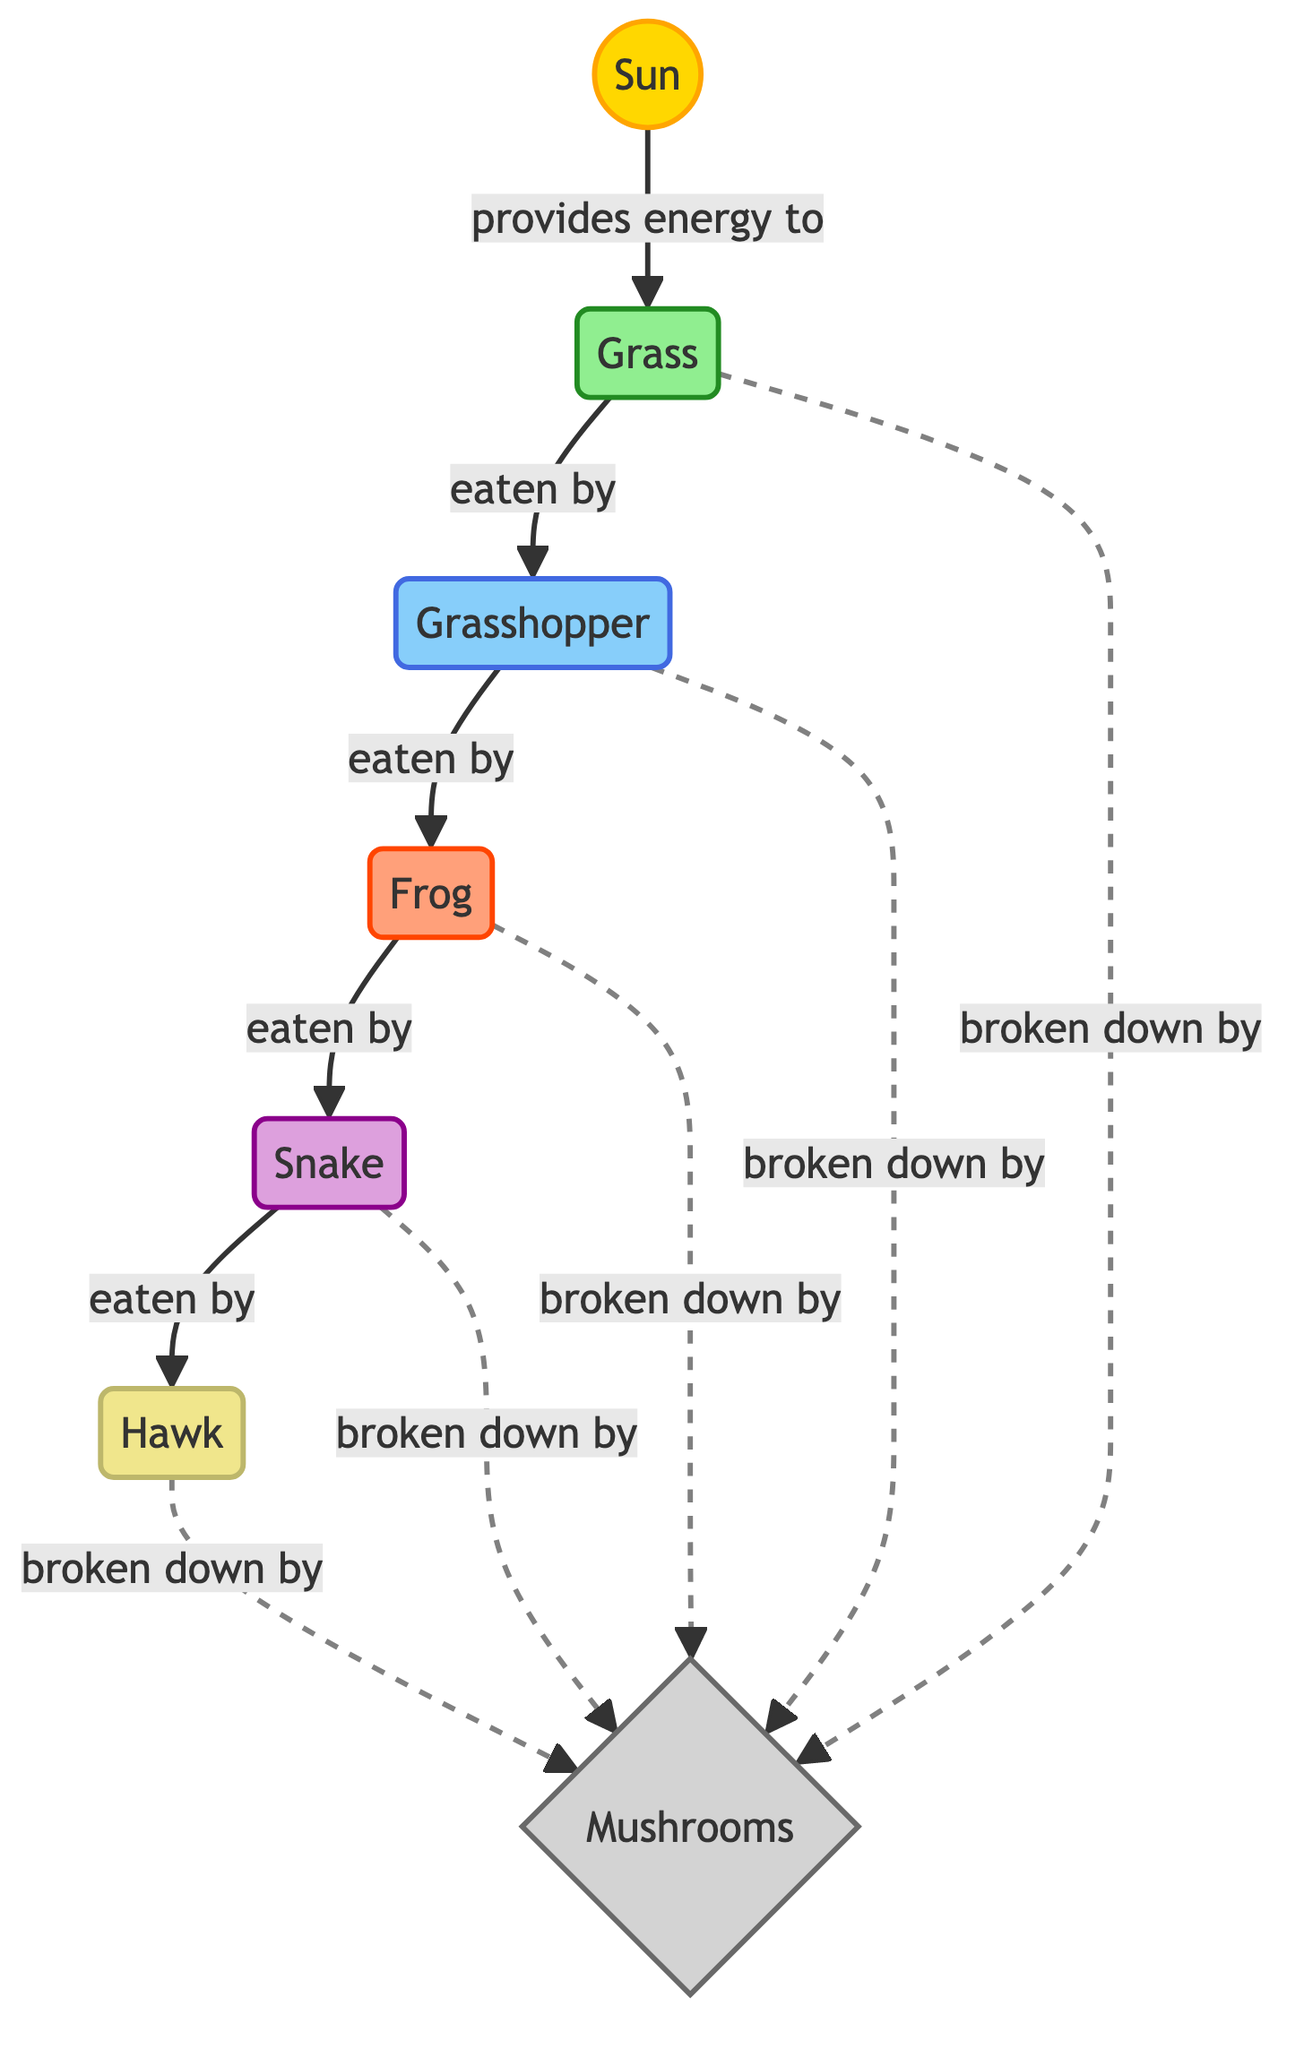What is the first trophic level in the diagram? The first trophic level is represented by the node labeled "Sun," which provides energy for the primary producer.
Answer: Sun How many primary consumers are in the diagram? The diagram shows one primary consumer, which is represented by the node labeled "Grasshopper."
Answer: 1 What organism is at the third trophic level? The third trophic level is occupied by the "Frog," which is a secondary consumer in the food chain.
Answer: Frog Which organism is broken down by decomposers? All organisms in the diagram are broken down by decomposers, including "Grass," "Grasshopper," "Frog," "Snake," and "Hawk." However, the question can refer to any specific one, such as "Hawk."
Answer: Hawk What relationship exists between the "Snake" and "Hawk"? The relationship is that the "Snake" is eaten by the "Hawk," as indicated by the arrow pointing from the Snake to the Hawk.
Answer: eaten by Why are mushrooms classified as decomposers? Mushrooms are classified as decomposers because they break down organic matter, as shown by the diagram where they are connected to all other trophic levels with dashed arrows indicating breakdown.
Answer: They break down organic matter How many trophic levels are represented in the diagram? The diagram has six distinct trophic levels: producers, primary consumers, secondary consumers, tertiary consumers, quaternary consumers, and decomposers.
Answer: 6 Who is at the top of the food chain? The top of the food chain is represented by the organism labeled "Hawk," which is the highest trophic level shown in the diagram.
Answer: Hawk What is the purpose of the arrows in the diagram? The arrows indicate the flow of energy from one trophic level to another, demonstrating how energy is transferred through the ecosystem.
Answer: Flow of energy 